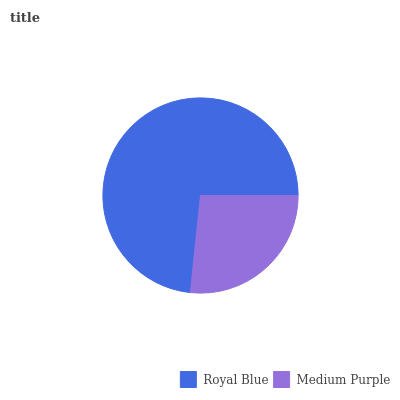Is Medium Purple the minimum?
Answer yes or no. Yes. Is Royal Blue the maximum?
Answer yes or no. Yes. Is Medium Purple the maximum?
Answer yes or no. No. Is Royal Blue greater than Medium Purple?
Answer yes or no. Yes. Is Medium Purple less than Royal Blue?
Answer yes or no. Yes. Is Medium Purple greater than Royal Blue?
Answer yes or no. No. Is Royal Blue less than Medium Purple?
Answer yes or no. No. Is Royal Blue the high median?
Answer yes or no. Yes. Is Medium Purple the low median?
Answer yes or no. Yes. Is Medium Purple the high median?
Answer yes or no. No. Is Royal Blue the low median?
Answer yes or no. No. 